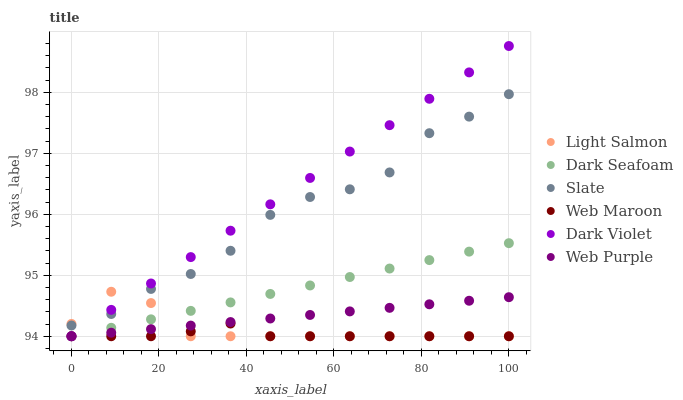Does Web Maroon have the minimum area under the curve?
Answer yes or no. Yes. Does Dark Violet have the maximum area under the curve?
Answer yes or no. Yes. Does Slate have the minimum area under the curve?
Answer yes or no. No. Does Slate have the maximum area under the curve?
Answer yes or no. No. Is Dark Seafoam the smoothest?
Answer yes or no. Yes. Is Slate the roughest?
Answer yes or no. Yes. Is Web Maroon the smoothest?
Answer yes or no. No. Is Web Maroon the roughest?
Answer yes or no. No. Does Light Salmon have the lowest value?
Answer yes or no. Yes. Does Slate have the lowest value?
Answer yes or no. No. Does Dark Violet have the highest value?
Answer yes or no. Yes. Does Slate have the highest value?
Answer yes or no. No. Is Dark Seafoam less than Slate?
Answer yes or no. Yes. Is Slate greater than Web Maroon?
Answer yes or no. Yes. Does Light Salmon intersect Dark Seafoam?
Answer yes or no. Yes. Is Light Salmon less than Dark Seafoam?
Answer yes or no. No. Is Light Salmon greater than Dark Seafoam?
Answer yes or no. No. Does Dark Seafoam intersect Slate?
Answer yes or no. No. 